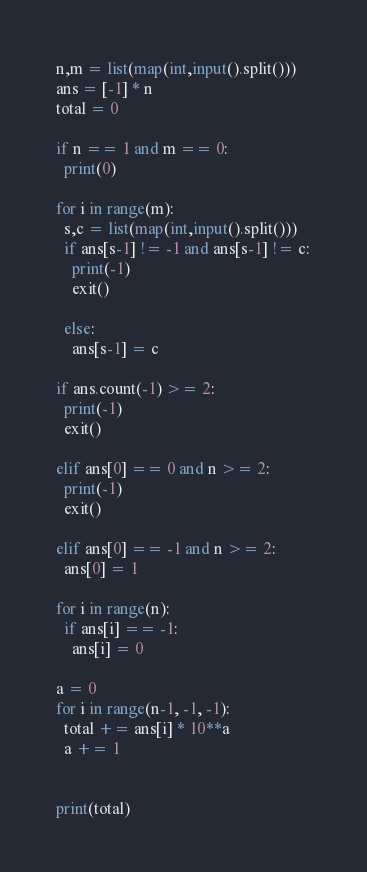<code> <loc_0><loc_0><loc_500><loc_500><_Python_>n,m = list(map(int,input().split()))
ans = [-1] * n
total = 0

if n == 1 and m == 0:
  print(0)
  
for i in range(m):
  s,c = list(map(int,input().split()))
  if ans[s-1] != -1 and ans[s-1] != c:
    print(-1)
    exit()
  
  else:
    ans[s-1] = c

if ans.count(-1) >= 2:
  print(-1)
  exit()
  
elif ans[0] == 0 and n >= 2:
  print(-1)
  exit()
  
elif ans[0] == -1 and n >= 2:
  ans[0] = 1
  
for i in range(n):
  if ans[i] == -1:
    ans[i] = 0
    
a = 0  
for i in range(n-1, -1, -1):
  total += ans[i] * 10**a
  a += 1
  

print(total)</code> 